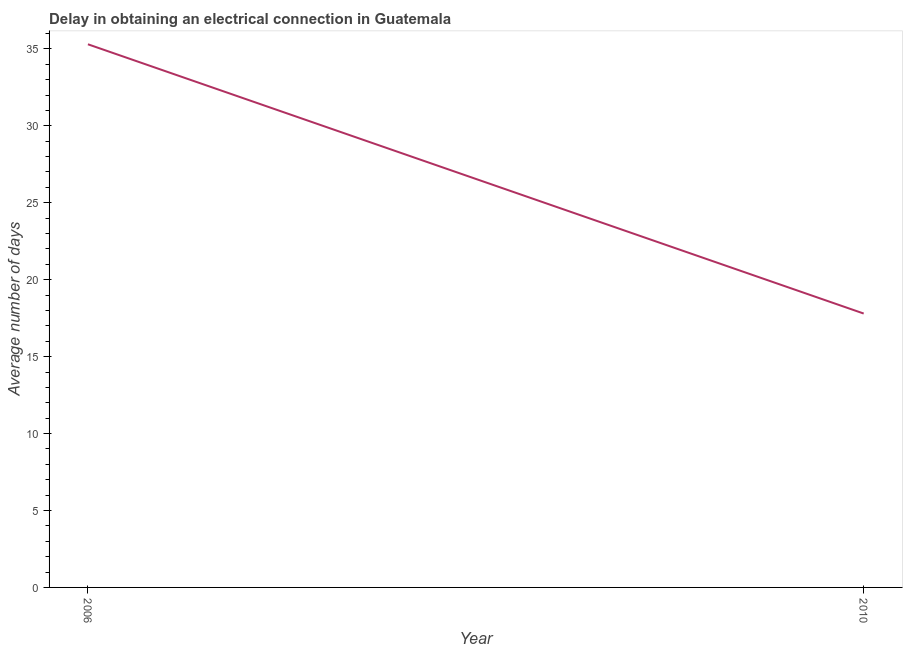What is the dalay in electrical connection in 2006?
Your response must be concise. 35.3. Across all years, what is the maximum dalay in electrical connection?
Provide a succinct answer. 35.3. In which year was the dalay in electrical connection maximum?
Your response must be concise. 2006. What is the sum of the dalay in electrical connection?
Ensure brevity in your answer.  53.1. What is the difference between the dalay in electrical connection in 2006 and 2010?
Provide a short and direct response. 17.5. What is the average dalay in electrical connection per year?
Your answer should be compact. 26.55. What is the median dalay in electrical connection?
Ensure brevity in your answer.  26.55. In how many years, is the dalay in electrical connection greater than 13 days?
Give a very brief answer. 2. Do a majority of the years between 2010 and 2006 (inclusive) have dalay in electrical connection greater than 3 days?
Make the answer very short. No. What is the ratio of the dalay in electrical connection in 2006 to that in 2010?
Your answer should be very brief. 1.98. In how many years, is the dalay in electrical connection greater than the average dalay in electrical connection taken over all years?
Your response must be concise. 1. How many years are there in the graph?
Offer a very short reply. 2. Are the values on the major ticks of Y-axis written in scientific E-notation?
Your answer should be compact. No. What is the title of the graph?
Offer a terse response. Delay in obtaining an electrical connection in Guatemala. What is the label or title of the Y-axis?
Your answer should be compact. Average number of days. What is the Average number of days in 2006?
Provide a succinct answer. 35.3. What is the Average number of days in 2010?
Give a very brief answer. 17.8. What is the ratio of the Average number of days in 2006 to that in 2010?
Your response must be concise. 1.98. 